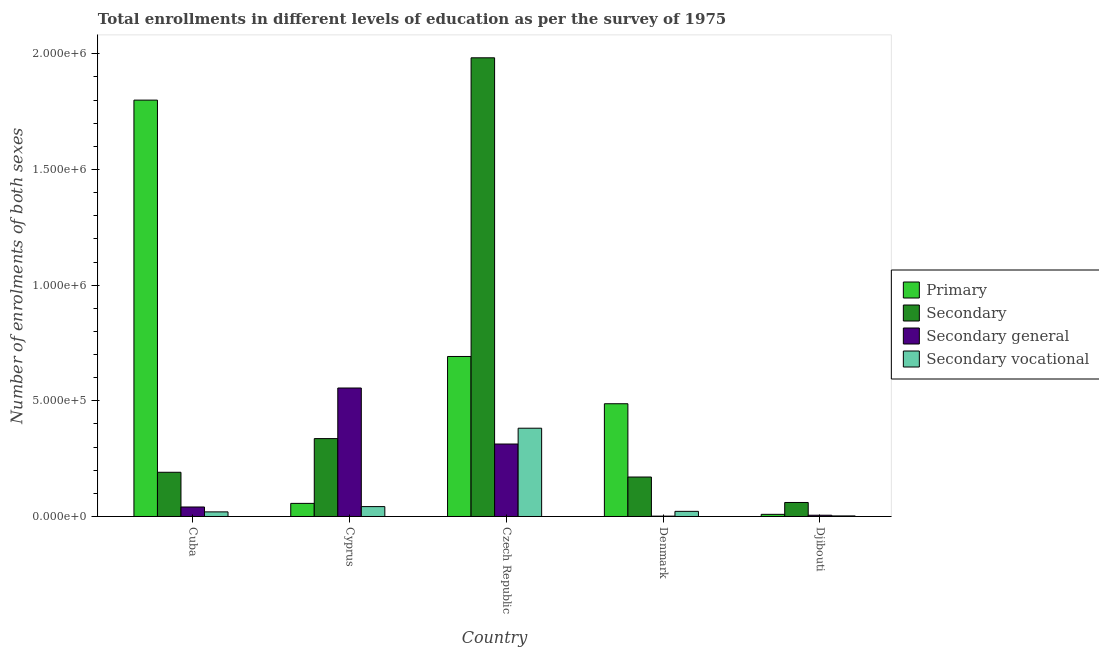How many groups of bars are there?
Offer a terse response. 5. How many bars are there on the 3rd tick from the left?
Offer a very short reply. 4. How many bars are there on the 1st tick from the right?
Provide a succinct answer. 4. In how many cases, is the number of bars for a given country not equal to the number of legend labels?
Give a very brief answer. 0. What is the number of enrolments in secondary education in Djibouti?
Make the answer very short. 6.06e+04. Across all countries, what is the maximum number of enrolments in secondary general education?
Ensure brevity in your answer.  5.55e+05. Across all countries, what is the minimum number of enrolments in secondary vocational education?
Your answer should be very brief. 2473. In which country was the number of enrolments in primary education maximum?
Offer a terse response. Cuba. What is the total number of enrolments in primary education in the graph?
Offer a terse response. 3.04e+06. What is the difference between the number of enrolments in secondary general education in Czech Republic and that in Denmark?
Your answer should be very brief. 3.12e+05. What is the difference between the number of enrolments in primary education in Denmark and the number of enrolments in secondary vocational education in Djibouti?
Your response must be concise. 4.85e+05. What is the average number of enrolments in secondary vocational education per country?
Make the answer very short. 9.38e+04. What is the difference between the number of enrolments in primary education and number of enrolments in secondary vocational education in Djibouti?
Keep it short and to the point. 6833. What is the ratio of the number of enrolments in secondary general education in Cuba to that in Denmark?
Provide a succinct answer. 26.41. What is the difference between the highest and the second highest number of enrolments in secondary general education?
Make the answer very short. 2.42e+05. What is the difference between the highest and the lowest number of enrolments in secondary vocational education?
Make the answer very short. 3.79e+05. Is it the case that in every country, the sum of the number of enrolments in secondary general education and number of enrolments in secondary education is greater than the sum of number of enrolments in primary education and number of enrolments in secondary vocational education?
Offer a very short reply. No. What does the 2nd bar from the left in Denmark represents?
Provide a succinct answer. Secondary. What does the 4th bar from the right in Djibouti represents?
Make the answer very short. Primary. Is it the case that in every country, the sum of the number of enrolments in primary education and number of enrolments in secondary education is greater than the number of enrolments in secondary general education?
Ensure brevity in your answer.  No. Are all the bars in the graph horizontal?
Ensure brevity in your answer.  No. How many countries are there in the graph?
Keep it short and to the point. 5. What is the difference between two consecutive major ticks on the Y-axis?
Keep it short and to the point. 5.00e+05. Are the values on the major ticks of Y-axis written in scientific E-notation?
Ensure brevity in your answer.  Yes. Does the graph contain grids?
Your answer should be very brief. No. Where does the legend appear in the graph?
Offer a terse response. Center right. What is the title of the graph?
Offer a very short reply. Total enrollments in different levels of education as per the survey of 1975. What is the label or title of the X-axis?
Ensure brevity in your answer.  Country. What is the label or title of the Y-axis?
Ensure brevity in your answer.  Number of enrolments of both sexes. What is the Number of enrolments of both sexes in Primary in Cuba?
Provide a succinct answer. 1.80e+06. What is the Number of enrolments of both sexes of Secondary in Cuba?
Offer a very short reply. 1.91e+05. What is the Number of enrolments of both sexes in Secondary general in Cuba?
Provide a succinct answer. 4.10e+04. What is the Number of enrolments of both sexes in Secondary vocational in Cuba?
Provide a short and direct response. 1.99e+04. What is the Number of enrolments of both sexes of Primary in Cyprus?
Your answer should be very brief. 5.66e+04. What is the Number of enrolments of both sexes in Secondary in Cyprus?
Give a very brief answer. 3.37e+05. What is the Number of enrolments of both sexes in Secondary general in Cyprus?
Give a very brief answer. 5.55e+05. What is the Number of enrolments of both sexes in Secondary vocational in Cyprus?
Your response must be concise. 4.27e+04. What is the Number of enrolments of both sexes of Primary in Czech Republic?
Provide a succinct answer. 6.92e+05. What is the Number of enrolments of both sexes in Secondary in Czech Republic?
Provide a succinct answer. 1.98e+06. What is the Number of enrolments of both sexes in Secondary general in Czech Republic?
Give a very brief answer. 3.13e+05. What is the Number of enrolments of both sexes of Secondary vocational in Czech Republic?
Provide a succinct answer. 3.82e+05. What is the Number of enrolments of both sexes of Primary in Denmark?
Provide a succinct answer. 4.87e+05. What is the Number of enrolments of both sexes in Secondary in Denmark?
Your answer should be compact. 1.71e+05. What is the Number of enrolments of both sexes of Secondary general in Denmark?
Provide a short and direct response. 1554. What is the Number of enrolments of both sexes of Secondary vocational in Denmark?
Ensure brevity in your answer.  2.22e+04. What is the Number of enrolments of both sexes in Primary in Djibouti?
Give a very brief answer. 9306. What is the Number of enrolments of both sexes of Secondary in Djibouti?
Offer a very short reply. 6.06e+04. What is the Number of enrolments of both sexes of Secondary general in Djibouti?
Offer a very short reply. 5434. What is the Number of enrolments of both sexes of Secondary vocational in Djibouti?
Provide a short and direct response. 2473. Across all countries, what is the maximum Number of enrolments of both sexes in Primary?
Make the answer very short. 1.80e+06. Across all countries, what is the maximum Number of enrolments of both sexes in Secondary?
Provide a succinct answer. 1.98e+06. Across all countries, what is the maximum Number of enrolments of both sexes in Secondary general?
Ensure brevity in your answer.  5.55e+05. Across all countries, what is the maximum Number of enrolments of both sexes in Secondary vocational?
Provide a succinct answer. 3.82e+05. Across all countries, what is the minimum Number of enrolments of both sexes of Primary?
Provide a short and direct response. 9306. Across all countries, what is the minimum Number of enrolments of both sexes in Secondary?
Make the answer very short. 6.06e+04. Across all countries, what is the minimum Number of enrolments of both sexes in Secondary general?
Your answer should be very brief. 1554. Across all countries, what is the minimum Number of enrolments of both sexes of Secondary vocational?
Ensure brevity in your answer.  2473. What is the total Number of enrolments of both sexes in Primary in the graph?
Your answer should be very brief. 3.04e+06. What is the total Number of enrolments of both sexes of Secondary in the graph?
Provide a succinct answer. 2.74e+06. What is the total Number of enrolments of both sexes in Secondary general in the graph?
Ensure brevity in your answer.  9.17e+05. What is the total Number of enrolments of both sexes of Secondary vocational in the graph?
Offer a very short reply. 4.69e+05. What is the difference between the Number of enrolments of both sexes of Primary in Cuba and that in Cyprus?
Give a very brief answer. 1.74e+06. What is the difference between the Number of enrolments of both sexes of Secondary in Cuba and that in Cyprus?
Your answer should be compact. -1.46e+05. What is the difference between the Number of enrolments of both sexes of Secondary general in Cuba and that in Cyprus?
Your answer should be very brief. -5.14e+05. What is the difference between the Number of enrolments of both sexes in Secondary vocational in Cuba and that in Cyprus?
Make the answer very short. -2.28e+04. What is the difference between the Number of enrolments of both sexes in Primary in Cuba and that in Czech Republic?
Make the answer very short. 1.11e+06. What is the difference between the Number of enrolments of both sexes in Secondary in Cuba and that in Czech Republic?
Your answer should be very brief. -1.79e+06. What is the difference between the Number of enrolments of both sexes in Secondary general in Cuba and that in Czech Republic?
Ensure brevity in your answer.  -2.72e+05. What is the difference between the Number of enrolments of both sexes of Secondary vocational in Cuba and that in Czech Republic?
Your response must be concise. -3.62e+05. What is the difference between the Number of enrolments of both sexes of Primary in Cuba and that in Denmark?
Offer a terse response. 1.31e+06. What is the difference between the Number of enrolments of both sexes in Secondary in Cuba and that in Denmark?
Keep it short and to the point. 2.05e+04. What is the difference between the Number of enrolments of both sexes of Secondary general in Cuba and that in Denmark?
Your answer should be compact. 3.95e+04. What is the difference between the Number of enrolments of both sexes of Secondary vocational in Cuba and that in Denmark?
Offer a very short reply. -2276. What is the difference between the Number of enrolments of both sexes in Primary in Cuba and that in Djibouti?
Ensure brevity in your answer.  1.79e+06. What is the difference between the Number of enrolments of both sexes of Secondary in Cuba and that in Djibouti?
Give a very brief answer. 1.31e+05. What is the difference between the Number of enrolments of both sexes of Secondary general in Cuba and that in Djibouti?
Offer a very short reply. 3.56e+04. What is the difference between the Number of enrolments of both sexes in Secondary vocational in Cuba and that in Djibouti?
Your answer should be very brief. 1.74e+04. What is the difference between the Number of enrolments of both sexes of Primary in Cyprus and that in Czech Republic?
Your answer should be very brief. -6.35e+05. What is the difference between the Number of enrolments of both sexes in Secondary in Cyprus and that in Czech Republic?
Give a very brief answer. -1.65e+06. What is the difference between the Number of enrolments of both sexes in Secondary general in Cyprus and that in Czech Republic?
Offer a terse response. 2.42e+05. What is the difference between the Number of enrolments of both sexes of Secondary vocational in Cyprus and that in Czech Republic?
Offer a very short reply. -3.39e+05. What is the difference between the Number of enrolments of both sexes in Primary in Cyprus and that in Denmark?
Keep it short and to the point. -4.31e+05. What is the difference between the Number of enrolments of both sexes of Secondary in Cyprus and that in Denmark?
Your response must be concise. 1.66e+05. What is the difference between the Number of enrolments of both sexes in Secondary general in Cyprus and that in Denmark?
Keep it short and to the point. 5.54e+05. What is the difference between the Number of enrolments of both sexes in Secondary vocational in Cyprus and that in Denmark?
Offer a very short reply. 2.05e+04. What is the difference between the Number of enrolments of both sexes of Primary in Cyprus and that in Djibouti?
Your answer should be compact. 4.73e+04. What is the difference between the Number of enrolments of both sexes in Secondary in Cyprus and that in Djibouti?
Your answer should be very brief. 2.76e+05. What is the difference between the Number of enrolments of both sexes in Secondary general in Cyprus and that in Djibouti?
Provide a short and direct response. 5.50e+05. What is the difference between the Number of enrolments of both sexes of Secondary vocational in Cyprus and that in Djibouti?
Offer a terse response. 4.02e+04. What is the difference between the Number of enrolments of both sexes of Primary in Czech Republic and that in Denmark?
Provide a short and direct response. 2.04e+05. What is the difference between the Number of enrolments of both sexes in Secondary in Czech Republic and that in Denmark?
Provide a succinct answer. 1.81e+06. What is the difference between the Number of enrolments of both sexes in Secondary general in Czech Republic and that in Denmark?
Your answer should be very brief. 3.12e+05. What is the difference between the Number of enrolments of both sexes in Secondary vocational in Czech Republic and that in Denmark?
Provide a short and direct response. 3.59e+05. What is the difference between the Number of enrolments of both sexes in Primary in Czech Republic and that in Djibouti?
Your answer should be compact. 6.82e+05. What is the difference between the Number of enrolments of both sexes of Secondary in Czech Republic and that in Djibouti?
Your response must be concise. 1.92e+06. What is the difference between the Number of enrolments of both sexes of Secondary general in Czech Republic and that in Djibouti?
Make the answer very short. 3.08e+05. What is the difference between the Number of enrolments of both sexes in Secondary vocational in Czech Republic and that in Djibouti?
Your response must be concise. 3.79e+05. What is the difference between the Number of enrolments of both sexes in Primary in Denmark and that in Djibouti?
Provide a short and direct response. 4.78e+05. What is the difference between the Number of enrolments of both sexes of Secondary in Denmark and that in Djibouti?
Your response must be concise. 1.10e+05. What is the difference between the Number of enrolments of both sexes of Secondary general in Denmark and that in Djibouti?
Make the answer very short. -3880. What is the difference between the Number of enrolments of both sexes of Secondary vocational in Denmark and that in Djibouti?
Keep it short and to the point. 1.97e+04. What is the difference between the Number of enrolments of both sexes in Primary in Cuba and the Number of enrolments of both sexes in Secondary in Cyprus?
Provide a succinct answer. 1.46e+06. What is the difference between the Number of enrolments of both sexes in Primary in Cuba and the Number of enrolments of both sexes in Secondary general in Cyprus?
Your answer should be compact. 1.24e+06. What is the difference between the Number of enrolments of both sexes in Primary in Cuba and the Number of enrolments of both sexes in Secondary vocational in Cyprus?
Provide a short and direct response. 1.76e+06. What is the difference between the Number of enrolments of both sexes in Secondary in Cuba and the Number of enrolments of both sexes in Secondary general in Cyprus?
Provide a short and direct response. -3.64e+05. What is the difference between the Number of enrolments of both sexes in Secondary in Cuba and the Number of enrolments of both sexes in Secondary vocational in Cyprus?
Keep it short and to the point. 1.48e+05. What is the difference between the Number of enrolments of both sexes of Secondary general in Cuba and the Number of enrolments of both sexes of Secondary vocational in Cyprus?
Ensure brevity in your answer.  -1684. What is the difference between the Number of enrolments of both sexes in Primary in Cuba and the Number of enrolments of both sexes in Secondary in Czech Republic?
Give a very brief answer. -1.83e+05. What is the difference between the Number of enrolments of both sexes in Primary in Cuba and the Number of enrolments of both sexes in Secondary general in Czech Republic?
Offer a very short reply. 1.49e+06. What is the difference between the Number of enrolments of both sexes in Primary in Cuba and the Number of enrolments of both sexes in Secondary vocational in Czech Republic?
Your answer should be compact. 1.42e+06. What is the difference between the Number of enrolments of both sexes in Secondary in Cuba and the Number of enrolments of both sexes in Secondary general in Czech Republic?
Make the answer very short. -1.22e+05. What is the difference between the Number of enrolments of both sexes of Secondary in Cuba and the Number of enrolments of both sexes of Secondary vocational in Czech Republic?
Keep it short and to the point. -1.90e+05. What is the difference between the Number of enrolments of both sexes in Secondary general in Cuba and the Number of enrolments of both sexes in Secondary vocational in Czech Republic?
Your answer should be very brief. -3.41e+05. What is the difference between the Number of enrolments of both sexes in Primary in Cuba and the Number of enrolments of both sexes in Secondary in Denmark?
Give a very brief answer. 1.63e+06. What is the difference between the Number of enrolments of both sexes in Primary in Cuba and the Number of enrolments of both sexes in Secondary general in Denmark?
Your answer should be very brief. 1.80e+06. What is the difference between the Number of enrolments of both sexes of Primary in Cuba and the Number of enrolments of both sexes of Secondary vocational in Denmark?
Give a very brief answer. 1.78e+06. What is the difference between the Number of enrolments of both sexes in Secondary in Cuba and the Number of enrolments of both sexes in Secondary general in Denmark?
Your response must be concise. 1.90e+05. What is the difference between the Number of enrolments of both sexes of Secondary in Cuba and the Number of enrolments of both sexes of Secondary vocational in Denmark?
Keep it short and to the point. 1.69e+05. What is the difference between the Number of enrolments of both sexes in Secondary general in Cuba and the Number of enrolments of both sexes in Secondary vocational in Denmark?
Your answer should be compact. 1.89e+04. What is the difference between the Number of enrolments of both sexes in Primary in Cuba and the Number of enrolments of both sexes in Secondary in Djibouti?
Your answer should be compact. 1.74e+06. What is the difference between the Number of enrolments of both sexes of Primary in Cuba and the Number of enrolments of both sexes of Secondary general in Djibouti?
Ensure brevity in your answer.  1.79e+06. What is the difference between the Number of enrolments of both sexes in Primary in Cuba and the Number of enrolments of both sexes in Secondary vocational in Djibouti?
Keep it short and to the point. 1.80e+06. What is the difference between the Number of enrolments of both sexes in Secondary in Cuba and the Number of enrolments of both sexes in Secondary general in Djibouti?
Provide a succinct answer. 1.86e+05. What is the difference between the Number of enrolments of both sexes in Secondary in Cuba and the Number of enrolments of both sexes in Secondary vocational in Djibouti?
Your response must be concise. 1.89e+05. What is the difference between the Number of enrolments of both sexes of Secondary general in Cuba and the Number of enrolments of both sexes of Secondary vocational in Djibouti?
Offer a terse response. 3.86e+04. What is the difference between the Number of enrolments of both sexes in Primary in Cyprus and the Number of enrolments of both sexes in Secondary in Czech Republic?
Provide a succinct answer. -1.93e+06. What is the difference between the Number of enrolments of both sexes of Primary in Cyprus and the Number of enrolments of both sexes of Secondary general in Czech Republic?
Keep it short and to the point. -2.57e+05. What is the difference between the Number of enrolments of both sexes of Primary in Cyprus and the Number of enrolments of both sexes of Secondary vocational in Czech Republic?
Ensure brevity in your answer.  -3.25e+05. What is the difference between the Number of enrolments of both sexes in Secondary in Cyprus and the Number of enrolments of both sexes in Secondary general in Czech Republic?
Keep it short and to the point. 2.35e+04. What is the difference between the Number of enrolments of both sexes in Secondary in Cyprus and the Number of enrolments of both sexes in Secondary vocational in Czech Republic?
Your answer should be compact. -4.49e+04. What is the difference between the Number of enrolments of both sexes in Secondary general in Cyprus and the Number of enrolments of both sexes in Secondary vocational in Czech Republic?
Make the answer very short. 1.74e+05. What is the difference between the Number of enrolments of both sexes in Primary in Cyprus and the Number of enrolments of both sexes in Secondary in Denmark?
Keep it short and to the point. -1.14e+05. What is the difference between the Number of enrolments of both sexes of Primary in Cyprus and the Number of enrolments of both sexes of Secondary general in Denmark?
Provide a short and direct response. 5.51e+04. What is the difference between the Number of enrolments of both sexes of Primary in Cyprus and the Number of enrolments of both sexes of Secondary vocational in Denmark?
Ensure brevity in your answer.  3.45e+04. What is the difference between the Number of enrolments of both sexes of Secondary in Cyprus and the Number of enrolments of both sexes of Secondary general in Denmark?
Keep it short and to the point. 3.35e+05. What is the difference between the Number of enrolments of both sexes of Secondary in Cyprus and the Number of enrolments of both sexes of Secondary vocational in Denmark?
Your response must be concise. 3.15e+05. What is the difference between the Number of enrolments of both sexes in Secondary general in Cyprus and the Number of enrolments of both sexes in Secondary vocational in Denmark?
Give a very brief answer. 5.33e+05. What is the difference between the Number of enrolments of both sexes in Primary in Cyprus and the Number of enrolments of both sexes in Secondary in Djibouti?
Your answer should be very brief. -3917. What is the difference between the Number of enrolments of both sexes in Primary in Cyprus and the Number of enrolments of both sexes in Secondary general in Djibouti?
Your answer should be very brief. 5.12e+04. What is the difference between the Number of enrolments of both sexes of Primary in Cyprus and the Number of enrolments of both sexes of Secondary vocational in Djibouti?
Give a very brief answer. 5.42e+04. What is the difference between the Number of enrolments of both sexes in Secondary in Cyprus and the Number of enrolments of both sexes in Secondary general in Djibouti?
Offer a terse response. 3.31e+05. What is the difference between the Number of enrolments of both sexes of Secondary in Cyprus and the Number of enrolments of both sexes of Secondary vocational in Djibouti?
Provide a short and direct response. 3.34e+05. What is the difference between the Number of enrolments of both sexes in Secondary general in Cyprus and the Number of enrolments of both sexes in Secondary vocational in Djibouti?
Give a very brief answer. 5.53e+05. What is the difference between the Number of enrolments of both sexes of Primary in Czech Republic and the Number of enrolments of both sexes of Secondary in Denmark?
Ensure brevity in your answer.  5.21e+05. What is the difference between the Number of enrolments of both sexes in Primary in Czech Republic and the Number of enrolments of both sexes in Secondary general in Denmark?
Your answer should be compact. 6.90e+05. What is the difference between the Number of enrolments of both sexes in Primary in Czech Republic and the Number of enrolments of both sexes in Secondary vocational in Denmark?
Give a very brief answer. 6.70e+05. What is the difference between the Number of enrolments of both sexes in Secondary in Czech Republic and the Number of enrolments of both sexes in Secondary general in Denmark?
Provide a succinct answer. 1.98e+06. What is the difference between the Number of enrolments of both sexes in Secondary in Czech Republic and the Number of enrolments of both sexes in Secondary vocational in Denmark?
Keep it short and to the point. 1.96e+06. What is the difference between the Number of enrolments of both sexes in Secondary general in Czech Republic and the Number of enrolments of both sexes in Secondary vocational in Denmark?
Your answer should be very brief. 2.91e+05. What is the difference between the Number of enrolments of both sexes in Primary in Czech Republic and the Number of enrolments of both sexes in Secondary in Djibouti?
Offer a very short reply. 6.31e+05. What is the difference between the Number of enrolments of both sexes of Primary in Czech Republic and the Number of enrolments of both sexes of Secondary general in Djibouti?
Offer a terse response. 6.86e+05. What is the difference between the Number of enrolments of both sexes of Primary in Czech Republic and the Number of enrolments of both sexes of Secondary vocational in Djibouti?
Your answer should be compact. 6.89e+05. What is the difference between the Number of enrolments of both sexes in Secondary in Czech Republic and the Number of enrolments of both sexes in Secondary general in Djibouti?
Offer a terse response. 1.98e+06. What is the difference between the Number of enrolments of both sexes in Secondary in Czech Republic and the Number of enrolments of both sexes in Secondary vocational in Djibouti?
Your answer should be very brief. 1.98e+06. What is the difference between the Number of enrolments of both sexes of Secondary general in Czech Republic and the Number of enrolments of both sexes of Secondary vocational in Djibouti?
Your response must be concise. 3.11e+05. What is the difference between the Number of enrolments of both sexes of Primary in Denmark and the Number of enrolments of both sexes of Secondary in Djibouti?
Offer a terse response. 4.27e+05. What is the difference between the Number of enrolments of both sexes in Primary in Denmark and the Number of enrolments of both sexes in Secondary general in Djibouti?
Your response must be concise. 4.82e+05. What is the difference between the Number of enrolments of both sexes of Primary in Denmark and the Number of enrolments of both sexes of Secondary vocational in Djibouti?
Ensure brevity in your answer.  4.85e+05. What is the difference between the Number of enrolments of both sexes in Secondary in Denmark and the Number of enrolments of both sexes in Secondary general in Djibouti?
Your answer should be compact. 1.65e+05. What is the difference between the Number of enrolments of both sexes of Secondary in Denmark and the Number of enrolments of both sexes of Secondary vocational in Djibouti?
Your answer should be compact. 1.68e+05. What is the difference between the Number of enrolments of both sexes of Secondary general in Denmark and the Number of enrolments of both sexes of Secondary vocational in Djibouti?
Keep it short and to the point. -919. What is the average Number of enrolments of both sexes of Primary per country?
Offer a terse response. 6.09e+05. What is the average Number of enrolments of both sexes in Secondary per country?
Offer a terse response. 5.48e+05. What is the average Number of enrolments of both sexes in Secondary general per country?
Your response must be concise. 1.83e+05. What is the average Number of enrolments of both sexes of Secondary vocational per country?
Your answer should be compact. 9.38e+04. What is the difference between the Number of enrolments of both sexes in Primary and Number of enrolments of both sexes in Secondary in Cuba?
Your answer should be compact. 1.61e+06. What is the difference between the Number of enrolments of both sexes in Primary and Number of enrolments of both sexes in Secondary general in Cuba?
Provide a succinct answer. 1.76e+06. What is the difference between the Number of enrolments of both sexes in Primary and Number of enrolments of both sexes in Secondary vocational in Cuba?
Make the answer very short. 1.78e+06. What is the difference between the Number of enrolments of both sexes of Secondary and Number of enrolments of both sexes of Secondary general in Cuba?
Your answer should be compact. 1.50e+05. What is the difference between the Number of enrolments of both sexes of Secondary and Number of enrolments of both sexes of Secondary vocational in Cuba?
Provide a succinct answer. 1.71e+05. What is the difference between the Number of enrolments of both sexes of Secondary general and Number of enrolments of both sexes of Secondary vocational in Cuba?
Offer a very short reply. 2.11e+04. What is the difference between the Number of enrolments of both sexes in Primary and Number of enrolments of both sexes in Secondary in Cyprus?
Your response must be concise. -2.80e+05. What is the difference between the Number of enrolments of both sexes of Primary and Number of enrolments of both sexes of Secondary general in Cyprus?
Give a very brief answer. -4.99e+05. What is the difference between the Number of enrolments of both sexes in Primary and Number of enrolments of both sexes in Secondary vocational in Cyprus?
Keep it short and to the point. 1.39e+04. What is the difference between the Number of enrolments of both sexes of Secondary and Number of enrolments of both sexes of Secondary general in Cyprus?
Keep it short and to the point. -2.19e+05. What is the difference between the Number of enrolments of both sexes in Secondary and Number of enrolments of both sexes in Secondary vocational in Cyprus?
Provide a succinct answer. 2.94e+05. What is the difference between the Number of enrolments of both sexes in Secondary general and Number of enrolments of both sexes in Secondary vocational in Cyprus?
Provide a short and direct response. 5.13e+05. What is the difference between the Number of enrolments of both sexes of Primary and Number of enrolments of both sexes of Secondary in Czech Republic?
Your answer should be compact. -1.29e+06. What is the difference between the Number of enrolments of both sexes of Primary and Number of enrolments of both sexes of Secondary general in Czech Republic?
Provide a short and direct response. 3.78e+05. What is the difference between the Number of enrolments of both sexes of Primary and Number of enrolments of both sexes of Secondary vocational in Czech Republic?
Give a very brief answer. 3.10e+05. What is the difference between the Number of enrolments of both sexes in Secondary and Number of enrolments of both sexes in Secondary general in Czech Republic?
Provide a short and direct response. 1.67e+06. What is the difference between the Number of enrolments of both sexes in Secondary and Number of enrolments of both sexes in Secondary vocational in Czech Republic?
Provide a succinct answer. 1.60e+06. What is the difference between the Number of enrolments of both sexes of Secondary general and Number of enrolments of both sexes of Secondary vocational in Czech Republic?
Give a very brief answer. -6.84e+04. What is the difference between the Number of enrolments of both sexes of Primary and Number of enrolments of both sexes of Secondary in Denmark?
Give a very brief answer. 3.17e+05. What is the difference between the Number of enrolments of both sexes in Primary and Number of enrolments of both sexes in Secondary general in Denmark?
Provide a short and direct response. 4.86e+05. What is the difference between the Number of enrolments of both sexes of Primary and Number of enrolments of both sexes of Secondary vocational in Denmark?
Provide a succinct answer. 4.65e+05. What is the difference between the Number of enrolments of both sexes in Secondary and Number of enrolments of both sexes in Secondary general in Denmark?
Give a very brief answer. 1.69e+05. What is the difference between the Number of enrolments of both sexes in Secondary and Number of enrolments of both sexes in Secondary vocational in Denmark?
Ensure brevity in your answer.  1.48e+05. What is the difference between the Number of enrolments of both sexes in Secondary general and Number of enrolments of both sexes in Secondary vocational in Denmark?
Ensure brevity in your answer.  -2.06e+04. What is the difference between the Number of enrolments of both sexes in Primary and Number of enrolments of both sexes in Secondary in Djibouti?
Keep it short and to the point. -5.13e+04. What is the difference between the Number of enrolments of both sexes of Primary and Number of enrolments of both sexes of Secondary general in Djibouti?
Your answer should be very brief. 3872. What is the difference between the Number of enrolments of both sexes in Primary and Number of enrolments of both sexes in Secondary vocational in Djibouti?
Offer a terse response. 6833. What is the difference between the Number of enrolments of both sexes of Secondary and Number of enrolments of both sexes of Secondary general in Djibouti?
Provide a short and direct response. 5.51e+04. What is the difference between the Number of enrolments of both sexes in Secondary and Number of enrolments of both sexes in Secondary vocational in Djibouti?
Give a very brief answer. 5.81e+04. What is the difference between the Number of enrolments of both sexes in Secondary general and Number of enrolments of both sexes in Secondary vocational in Djibouti?
Your answer should be very brief. 2961. What is the ratio of the Number of enrolments of both sexes of Primary in Cuba to that in Cyprus?
Provide a short and direct response. 31.77. What is the ratio of the Number of enrolments of both sexes of Secondary in Cuba to that in Cyprus?
Offer a terse response. 0.57. What is the ratio of the Number of enrolments of both sexes in Secondary general in Cuba to that in Cyprus?
Your answer should be very brief. 0.07. What is the ratio of the Number of enrolments of both sexes of Secondary vocational in Cuba to that in Cyprus?
Provide a short and direct response. 0.47. What is the ratio of the Number of enrolments of both sexes in Primary in Cuba to that in Czech Republic?
Provide a succinct answer. 2.6. What is the ratio of the Number of enrolments of both sexes in Secondary in Cuba to that in Czech Republic?
Make the answer very short. 0.1. What is the ratio of the Number of enrolments of both sexes of Secondary general in Cuba to that in Czech Republic?
Provide a succinct answer. 0.13. What is the ratio of the Number of enrolments of both sexes in Secondary vocational in Cuba to that in Czech Republic?
Offer a terse response. 0.05. What is the ratio of the Number of enrolments of both sexes of Primary in Cuba to that in Denmark?
Ensure brevity in your answer.  3.69. What is the ratio of the Number of enrolments of both sexes in Secondary in Cuba to that in Denmark?
Your answer should be very brief. 1.12. What is the ratio of the Number of enrolments of both sexes of Secondary general in Cuba to that in Denmark?
Your answer should be compact. 26.41. What is the ratio of the Number of enrolments of both sexes in Secondary vocational in Cuba to that in Denmark?
Ensure brevity in your answer.  0.9. What is the ratio of the Number of enrolments of both sexes of Primary in Cuba to that in Djibouti?
Make the answer very short. 193.41. What is the ratio of the Number of enrolments of both sexes of Secondary in Cuba to that in Djibouti?
Your answer should be compact. 3.16. What is the ratio of the Number of enrolments of both sexes of Secondary general in Cuba to that in Djibouti?
Provide a short and direct response. 7.55. What is the ratio of the Number of enrolments of both sexes of Secondary vocational in Cuba to that in Djibouti?
Your answer should be very brief. 8.05. What is the ratio of the Number of enrolments of both sexes of Primary in Cyprus to that in Czech Republic?
Your answer should be very brief. 0.08. What is the ratio of the Number of enrolments of both sexes of Secondary in Cyprus to that in Czech Republic?
Ensure brevity in your answer.  0.17. What is the ratio of the Number of enrolments of both sexes of Secondary general in Cyprus to that in Czech Republic?
Ensure brevity in your answer.  1.77. What is the ratio of the Number of enrolments of both sexes of Secondary vocational in Cyprus to that in Czech Republic?
Make the answer very short. 0.11. What is the ratio of the Number of enrolments of both sexes in Primary in Cyprus to that in Denmark?
Offer a terse response. 0.12. What is the ratio of the Number of enrolments of both sexes of Secondary in Cyprus to that in Denmark?
Ensure brevity in your answer.  1.97. What is the ratio of the Number of enrolments of both sexes in Secondary general in Cyprus to that in Denmark?
Make the answer very short. 357.39. What is the ratio of the Number of enrolments of both sexes of Secondary vocational in Cyprus to that in Denmark?
Your response must be concise. 1.93. What is the ratio of the Number of enrolments of both sexes in Primary in Cyprus to that in Djibouti?
Make the answer very short. 6.09. What is the ratio of the Number of enrolments of both sexes in Secondary in Cyprus to that in Djibouti?
Your answer should be very brief. 5.56. What is the ratio of the Number of enrolments of both sexes in Secondary general in Cyprus to that in Djibouti?
Provide a succinct answer. 102.21. What is the ratio of the Number of enrolments of both sexes of Secondary vocational in Cyprus to that in Djibouti?
Keep it short and to the point. 17.27. What is the ratio of the Number of enrolments of both sexes in Primary in Czech Republic to that in Denmark?
Keep it short and to the point. 1.42. What is the ratio of the Number of enrolments of both sexes in Secondary in Czech Republic to that in Denmark?
Offer a terse response. 11.62. What is the ratio of the Number of enrolments of both sexes in Secondary general in Czech Republic to that in Denmark?
Offer a terse response. 201.55. What is the ratio of the Number of enrolments of both sexes in Secondary vocational in Czech Republic to that in Denmark?
Ensure brevity in your answer.  17.21. What is the ratio of the Number of enrolments of both sexes of Primary in Czech Republic to that in Djibouti?
Provide a short and direct response. 74.33. What is the ratio of the Number of enrolments of both sexes in Secondary in Czech Republic to that in Djibouti?
Give a very brief answer. 32.74. What is the ratio of the Number of enrolments of both sexes of Secondary general in Czech Republic to that in Djibouti?
Give a very brief answer. 57.64. What is the ratio of the Number of enrolments of both sexes in Secondary vocational in Czech Republic to that in Djibouti?
Your answer should be very brief. 154.3. What is the ratio of the Number of enrolments of both sexes of Primary in Denmark to that in Djibouti?
Your answer should be very brief. 52.37. What is the ratio of the Number of enrolments of both sexes of Secondary in Denmark to that in Djibouti?
Your answer should be very brief. 2.82. What is the ratio of the Number of enrolments of both sexes of Secondary general in Denmark to that in Djibouti?
Ensure brevity in your answer.  0.29. What is the ratio of the Number of enrolments of both sexes in Secondary vocational in Denmark to that in Djibouti?
Ensure brevity in your answer.  8.97. What is the difference between the highest and the second highest Number of enrolments of both sexes in Primary?
Ensure brevity in your answer.  1.11e+06. What is the difference between the highest and the second highest Number of enrolments of both sexes of Secondary?
Your response must be concise. 1.65e+06. What is the difference between the highest and the second highest Number of enrolments of both sexes in Secondary general?
Ensure brevity in your answer.  2.42e+05. What is the difference between the highest and the second highest Number of enrolments of both sexes of Secondary vocational?
Your response must be concise. 3.39e+05. What is the difference between the highest and the lowest Number of enrolments of both sexes of Primary?
Provide a short and direct response. 1.79e+06. What is the difference between the highest and the lowest Number of enrolments of both sexes in Secondary?
Your answer should be compact. 1.92e+06. What is the difference between the highest and the lowest Number of enrolments of both sexes of Secondary general?
Give a very brief answer. 5.54e+05. What is the difference between the highest and the lowest Number of enrolments of both sexes of Secondary vocational?
Provide a succinct answer. 3.79e+05. 